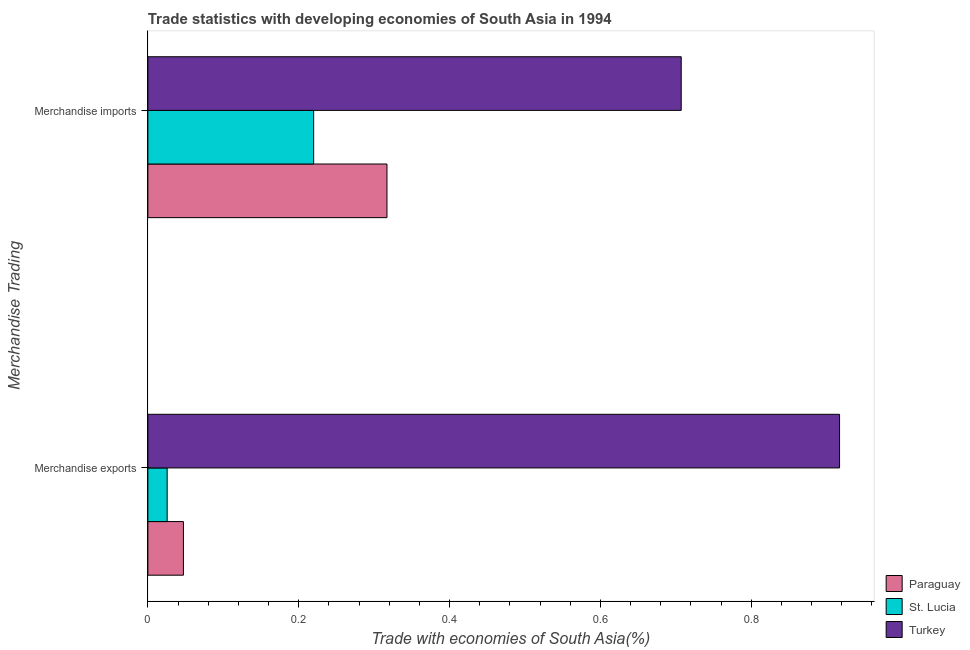How many groups of bars are there?
Provide a succinct answer. 2. Are the number of bars per tick equal to the number of legend labels?
Ensure brevity in your answer.  Yes. How many bars are there on the 1st tick from the top?
Ensure brevity in your answer.  3. What is the merchandise imports in St. Lucia?
Ensure brevity in your answer.  0.22. Across all countries, what is the maximum merchandise imports?
Provide a short and direct response. 0.71. Across all countries, what is the minimum merchandise exports?
Give a very brief answer. 0.03. In which country was the merchandise exports minimum?
Provide a short and direct response. St. Lucia. What is the total merchandise exports in the graph?
Your response must be concise. 0.99. What is the difference between the merchandise imports in St. Lucia and that in Paraguay?
Provide a succinct answer. -0.1. What is the difference between the merchandise imports in Turkey and the merchandise exports in Paraguay?
Give a very brief answer. 0.66. What is the average merchandise imports per country?
Ensure brevity in your answer.  0.41. What is the difference between the merchandise exports and merchandise imports in Turkey?
Give a very brief answer. 0.21. In how many countries, is the merchandise imports greater than 0.44 %?
Your answer should be compact. 1. What is the ratio of the merchandise exports in Turkey to that in Paraguay?
Provide a short and direct response. 19.46. What does the 2nd bar from the top in Merchandise exports represents?
Offer a terse response. St. Lucia. What does the 1st bar from the bottom in Merchandise imports represents?
Offer a terse response. Paraguay. Are the values on the major ticks of X-axis written in scientific E-notation?
Provide a short and direct response. No. Where does the legend appear in the graph?
Your response must be concise. Bottom right. How many legend labels are there?
Keep it short and to the point. 3. How are the legend labels stacked?
Your answer should be compact. Vertical. What is the title of the graph?
Your answer should be very brief. Trade statistics with developing economies of South Asia in 1994. Does "Cambodia" appear as one of the legend labels in the graph?
Offer a very short reply. No. What is the label or title of the X-axis?
Your answer should be compact. Trade with economies of South Asia(%). What is the label or title of the Y-axis?
Ensure brevity in your answer.  Merchandise Trading. What is the Trade with economies of South Asia(%) in Paraguay in Merchandise exports?
Your answer should be compact. 0.05. What is the Trade with economies of South Asia(%) in St. Lucia in Merchandise exports?
Keep it short and to the point. 0.03. What is the Trade with economies of South Asia(%) of Turkey in Merchandise exports?
Offer a very short reply. 0.92. What is the Trade with economies of South Asia(%) of Paraguay in Merchandise imports?
Offer a terse response. 0.32. What is the Trade with economies of South Asia(%) of St. Lucia in Merchandise imports?
Your answer should be compact. 0.22. What is the Trade with economies of South Asia(%) of Turkey in Merchandise imports?
Provide a succinct answer. 0.71. Across all Merchandise Trading, what is the maximum Trade with economies of South Asia(%) in Paraguay?
Provide a succinct answer. 0.32. Across all Merchandise Trading, what is the maximum Trade with economies of South Asia(%) in St. Lucia?
Make the answer very short. 0.22. Across all Merchandise Trading, what is the maximum Trade with economies of South Asia(%) in Turkey?
Offer a terse response. 0.92. Across all Merchandise Trading, what is the minimum Trade with economies of South Asia(%) in Paraguay?
Offer a terse response. 0.05. Across all Merchandise Trading, what is the minimum Trade with economies of South Asia(%) in St. Lucia?
Offer a very short reply. 0.03. Across all Merchandise Trading, what is the minimum Trade with economies of South Asia(%) in Turkey?
Provide a short and direct response. 0.71. What is the total Trade with economies of South Asia(%) in Paraguay in the graph?
Make the answer very short. 0.36. What is the total Trade with economies of South Asia(%) of St. Lucia in the graph?
Your response must be concise. 0.25. What is the total Trade with economies of South Asia(%) in Turkey in the graph?
Your answer should be compact. 1.62. What is the difference between the Trade with economies of South Asia(%) in Paraguay in Merchandise exports and that in Merchandise imports?
Make the answer very short. -0.27. What is the difference between the Trade with economies of South Asia(%) in St. Lucia in Merchandise exports and that in Merchandise imports?
Offer a terse response. -0.19. What is the difference between the Trade with economies of South Asia(%) in Turkey in Merchandise exports and that in Merchandise imports?
Your answer should be very brief. 0.21. What is the difference between the Trade with economies of South Asia(%) of Paraguay in Merchandise exports and the Trade with economies of South Asia(%) of St. Lucia in Merchandise imports?
Keep it short and to the point. -0.17. What is the difference between the Trade with economies of South Asia(%) of Paraguay in Merchandise exports and the Trade with economies of South Asia(%) of Turkey in Merchandise imports?
Provide a short and direct response. -0.66. What is the difference between the Trade with economies of South Asia(%) of St. Lucia in Merchandise exports and the Trade with economies of South Asia(%) of Turkey in Merchandise imports?
Your answer should be very brief. -0.68. What is the average Trade with economies of South Asia(%) in Paraguay per Merchandise Trading?
Make the answer very short. 0.18. What is the average Trade with economies of South Asia(%) in St. Lucia per Merchandise Trading?
Give a very brief answer. 0.12. What is the average Trade with economies of South Asia(%) in Turkey per Merchandise Trading?
Offer a terse response. 0.81. What is the difference between the Trade with economies of South Asia(%) in Paraguay and Trade with economies of South Asia(%) in St. Lucia in Merchandise exports?
Ensure brevity in your answer.  0.02. What is the difference between the Trade with economies of South Asia(%) of Paraguay and Trade with economies of South Asia(%) of Turkey in Merchandise exports?
Give a very brief answer. -0.87. What is the difference between the Trade with economies of South Asia(%) of St. Lucia and Trade with economies of South Asia(%) of Turkey in Merchandise exports?
Ensure brevity in your answer.  -0.89. What is the difference between the Trade with economies of South Asia(%) of Paraguay and Trade with economies of South Asia(%) of St. Lucia in Merchandise imports?
Your response must be concise. 0.1. What is the difference between the Trade with economies of South Asia(%) in Paraguay and Trade with economies of South Asia(%) in Turkey in Merchandise imports?
Provide a short and direct response. -0.39. What is the difference between the Trade with economies of South Asia(%) of St. Lucia and Trade with economies of South Asia(%) of Turkey in Merchandise imports?
Your answer should be very brief. -0.49. What is the ratio of the Trade with economies of South Asia(%) of Paraguay in Merchandise exports to that in Merchandise imports?
Provide a succinct answer. 0.15. What is the ratio of the Trade with economies of South Asia(%) in St. Lucia in Merchandise exports to that in Merchandise imports?
Offer a very short reply. 0.12. What is the ratio of the Trade with economies of South Asia(%) of Turkey in Merchandise exports to that in Merchandise imports?
Provide a succinct answer. 1.3. What is the difference between the highest and the second highest Trade with economies of South Asia(%) of Paraguay?
Provide a short and direct response. 0.27. What is the difference between the highest and the second highest Trade with economies of South Asia(%) in St. Lucia?
Your response must be concise. 0.19. What is the difference between the highest and the second highest Trade with economies of South Asia(%) of Turkey?
Offer a very short reply. 0.21. What is the difference between the highest and the lowest Trade with economies of South Asia(%) of Paraguay?
Your answer should be compact. 0.27. What is the difference between the highest and the lowest Trade with economies of South Asia(%) in St. Lucia?
Keep it short and to the point. 0.19. What is the difference between the highest and the lowest Trade with economies of South Asia(%) in Turkey?
Provide a short and direct response. 0.21. 